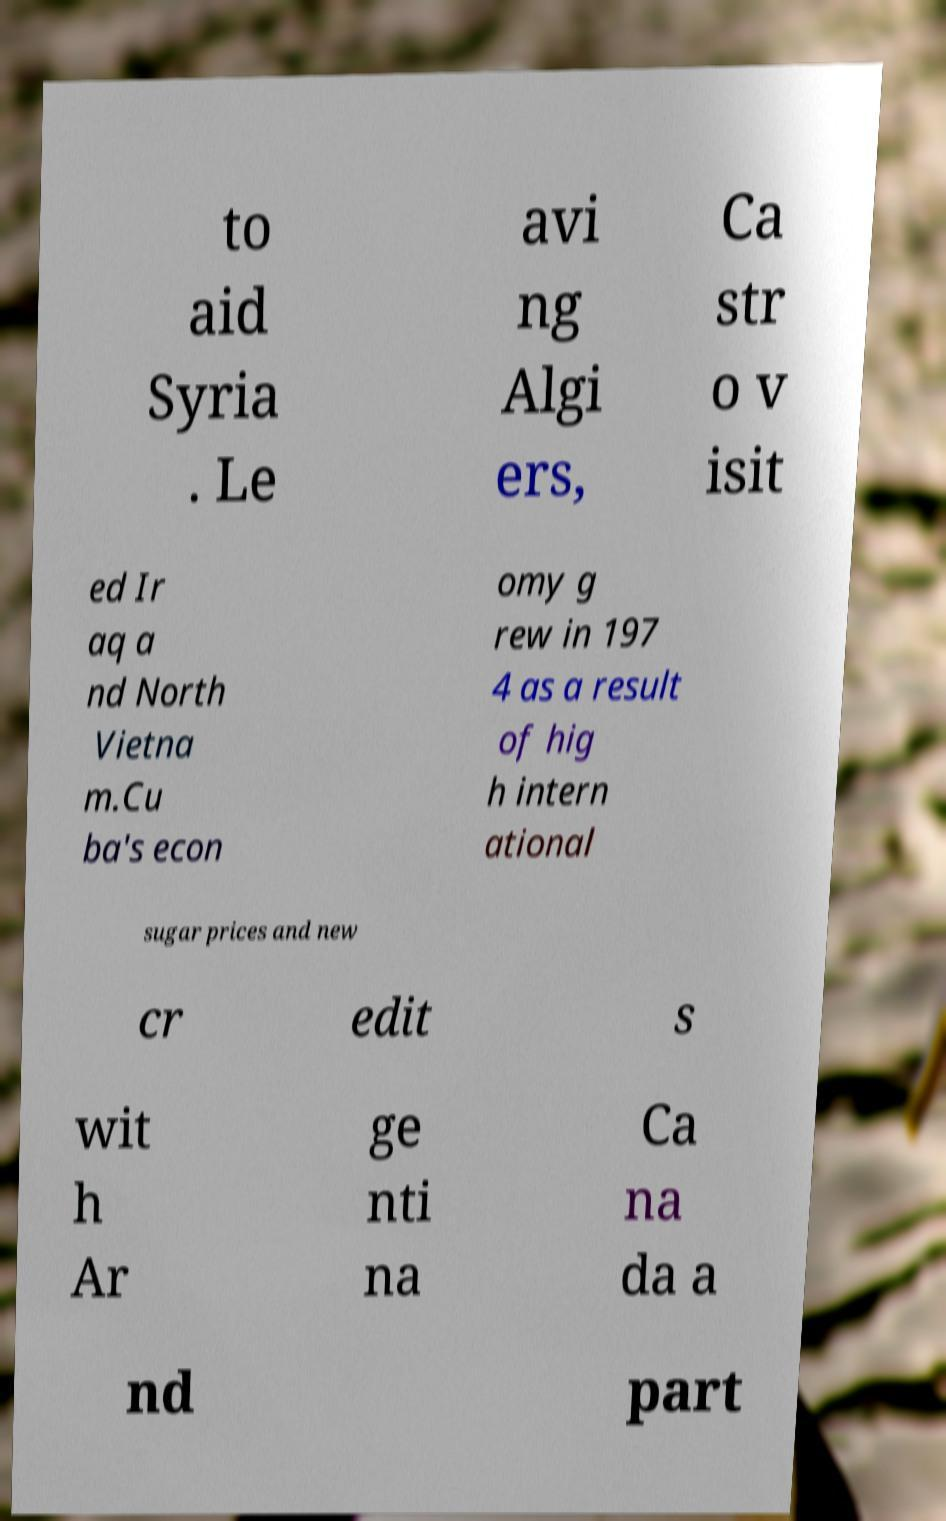I need the written content from this picture converted into text. Can you do that? to aid Syria . Le avi ng Algi ers, Ca str o v isit ed Ir aq a nd North Vietna m.Cu ba's econ omy g rew in 197 4 as a result of hig h intern ational sugar prices and new cr edit s wit h Ar ge nti na Ca na da a nd part 